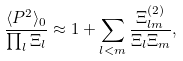<formula> <loc_0><loc_0><loc_500><loc_500>\frac { \langle P ^ { 2 } \rangle _ { 0 } } { \prod _ { l } \Xi _ { l } } \approx 1 + \sum _ { l < m } \frac { \Xi ^ { ( 2 ) } _ { l m } } { \Xi _ { l } \Xi _ { m } } ,</formula> 